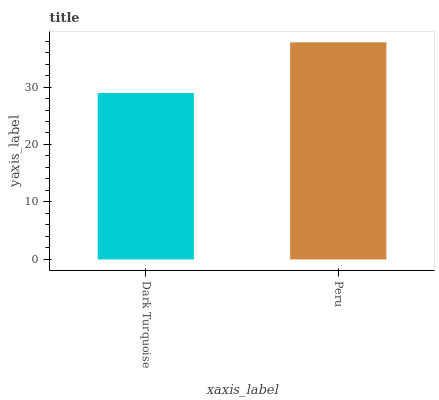Is Dark Turquoise the minimum?
Answer yes or no. Yes. Is Peru the maximum?
Answer yes or no. Yes. Is Peru the minimum?
Answer yes or no. No. Is Peru greater than Dark Turquoise?
Answer yes or no. Yes. Is Dark Turquoise less than Peru?
Answer yes or no. Yes. Is Dark Turquoise greater than Peru?
Answer yes or no. No. Is Peru less than Dark Turquoise?
Answer yes or no. No. Is Peru the high median?
Answer yes or no. Yes. Is Dark Turquoise the low median?
Answer yes or no. Yes. Is Dark Turquoise the high median?
Answer yes or no. No. Is Peru the low median?
Answer yes or no. No. 